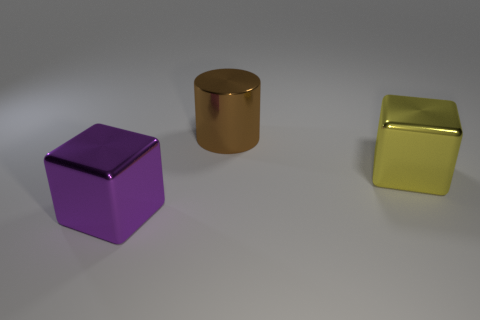Add 1 big shiny cylinders. How many objects exist? 4 Subtract all purple cubes. How many cubes are left? 1 Subtract all cylinders. How many objects are left? 2 Add 1 big objects. How many big objects are left? 4 Add 1 large gray matte objects. How many large gray matte objects exist? 1 Subtract 0 green cylinders. How many objects are left? 3 Subtract all green cubes. Subtract all gray cylinders. How many cubes are left? 2 Subtract all brown blocks. Subtract all metallic blocks. How many objects are left? 1 